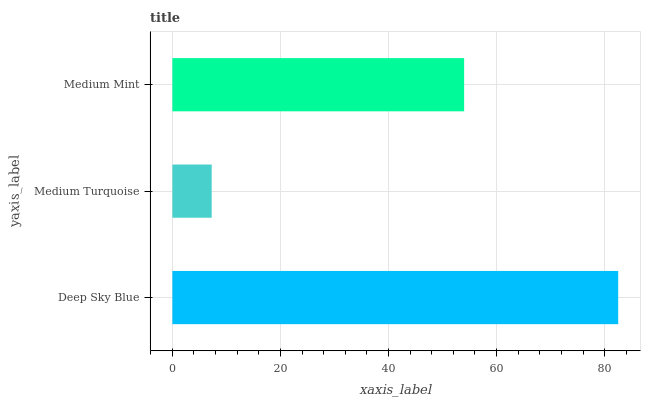Is Medium Turquoise the minimum?
Answer yes or no. Yes. Is Deep Sky Blue the maximum?
Answer yes or no. Yes. Is Medium Mint the minimum?
Answer yes or no. No. Is Medium Mint the maximum?
Answer yes or no. No. Is Medium Mint greater than Medium Turquoise?
Answer yes or no. Yes. Is Medium Turquoise less than Medium Mint?
Answer yes or no. Yes. Is Medium Turquoise greater than Medium Mint?
Answer yes or no. No. Is Medium Mint less than Medium Turquoise?
Answer yes or no. No. Is Medium Mint the high median?
Answer yes or no. Yes. Is Medium Mint the low median?
Answer yes or no. Yes. Is Medium Turquoise the high median?
Answer yes or no. No. Is Deep Sky Blue the low median?
Answer yes or no. No. 